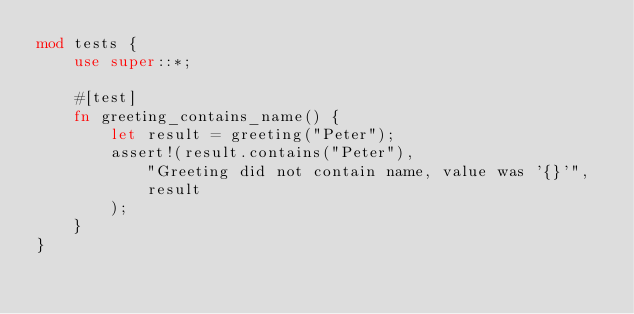Convert code to text. <code><loc_0><loc_0><loc_500><loc_500><_Rust_>mod tests {
    use super::*;

    #[test]
    fn greeting_contains_name() {
        let result = greeting("Peter");
        assert!(result.contains("Peter"),
            "Greeting did not contain name, value was '{}'",
            result
        );
    }
}
</code> 